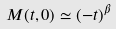Convert formula to latex. <formula><loc_0><loc_0><loc_500><loc_500>M ( t , 0 ) \simeq ( - t ) ^ { \beta }</formula> 